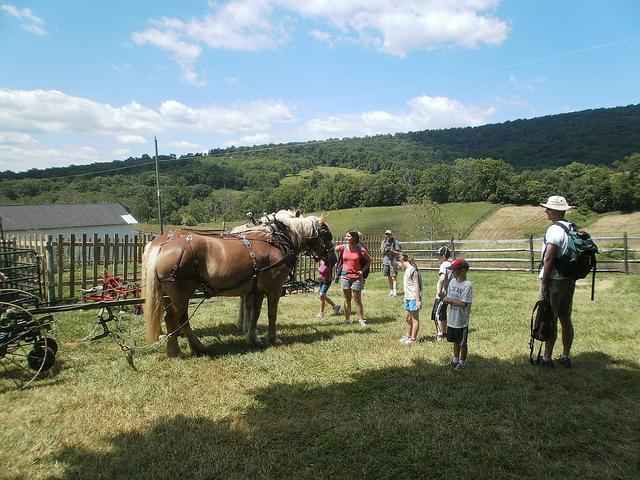How many people can be seen?
Give a very brief answer. 7. How many people are visible?
Give a very brief answer. 3. 